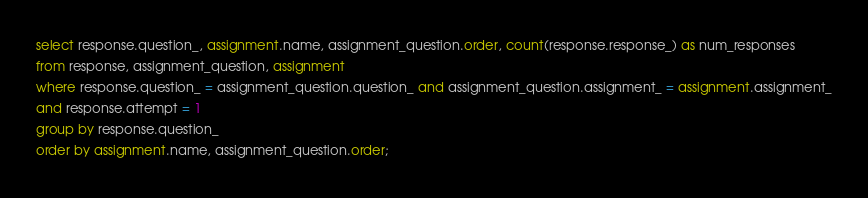<code> <loc_0><loc_0><loc_500><loc_500><_SQL_>select response.question_, assignment.name, assignment_question.order, count(response.response_) as num_responses
from response, assignment_question, assignment
where response.question_ = assignment_question.question_ and assignment_question.assignment_ = assignment.assignment_
and response.attempt = 1
group by response.question_
order by assignment.name, assignment_question.order;</code> 